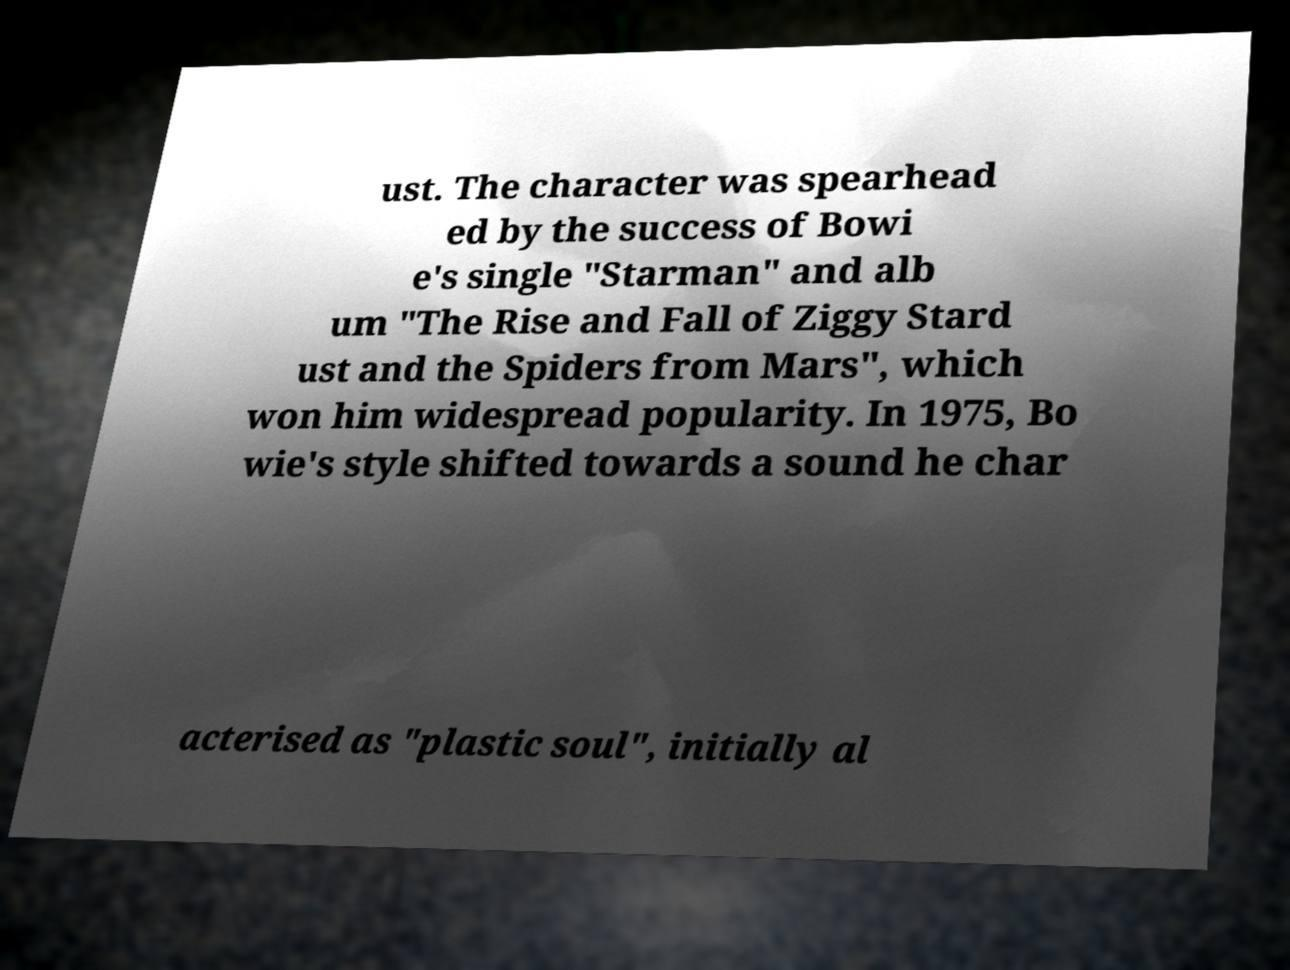Can you accurately transcribe the text from the provided image for me? ust. The character was spearhead ed by the success of Bowi e's single "Starman" and alb um "The Rise and Fall of Ziggy Stard ust and the Spiders from Mars", which won him widespread popularity. In 1975, Bo wie's style shifted towards a sound he char acterised as "plastic soul", initially al 